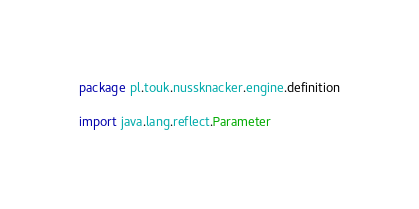Convert code to text. <code><loc_0><loc_0><loc_500><loc_500><_Scala_>package pl.touk.nussknacker.engine.definition

import java.lang.reflect.Parameter
</code> 